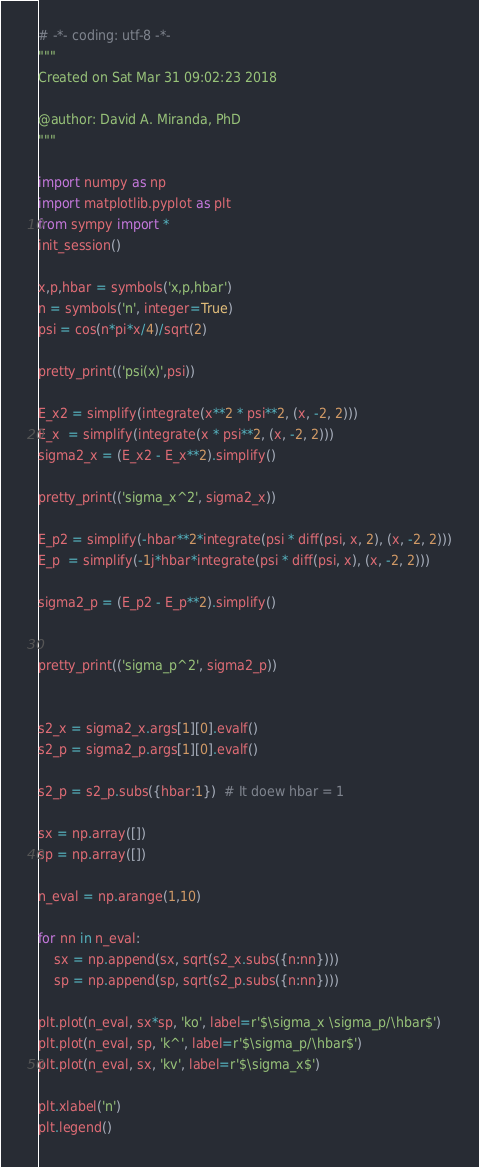Convert code to text. <code><loc_0><loc_0><loc_500><loc_500><_Python_># -*- coding: utf-8 -*-
"""
Created on Sat Mar 31 09:02:23 2018

@author: David A. Miranda, PhD
"""

import numpy as np
import matplotlib.pyplot as plt
from sympy import *
init_session()

x,p,hbar = symbols('x,p,hbar')
n = symbols('n', integer=True)
psi = cos(n*pi*x/4)/sqrt(2)

pretty_print(('psi(x)',psi))

E_x2 = simplify(integrate(x**2 * psi**2, (x, -2, 2)))
E_x  = simplify(integrate(x * psi**2, (x, -2, 2)))
sigma2_x = (E_x2 - E_x**2).simplify()

pretty_print(('sigma_x^2', sigma2_x))

E_p2 = simplify(-hbar**2*integrate(psi * diff(psi, x, 2), (x, -2, 2)))
E_p  = simplify(-1j*hbar*integrate(psi * diff(psi, x), (x, -2, 2)))

sigma2_p = (E_p2 - E_p**2).simplify()


pretty_print(('sigma_p^2', sigma2_p))


s2_x = sigma2_x.args[1][0].evalf()
s2_p = sigma2_p.args[1][0].evalf()

s2_p = s2_p.subs({hbar:1})  # It doew hbar = 1

sx = np.array([])
sp = np.array([])

n_eval = np.arange(1,10)

for nn in n_eval:
    sx = np.append(sx, sqrt(s2_x.subs({n:nn})))
    sp = np.append(sp, sqrt(s2_p.subs({n:nn})))

plt.plot(n_eval, sx*sp, 'ko', label=r'$\sigma_x \sigma_p/\hbar$')
plt.plot(n_eval, sp, 'k^', label=r'$\sigma_p/\hbar$')
plt.plot(n_eval, sx, 'kv', label=r'$\sigma_x$')

plt.xlabel('n')
plt.legend()
</code> 